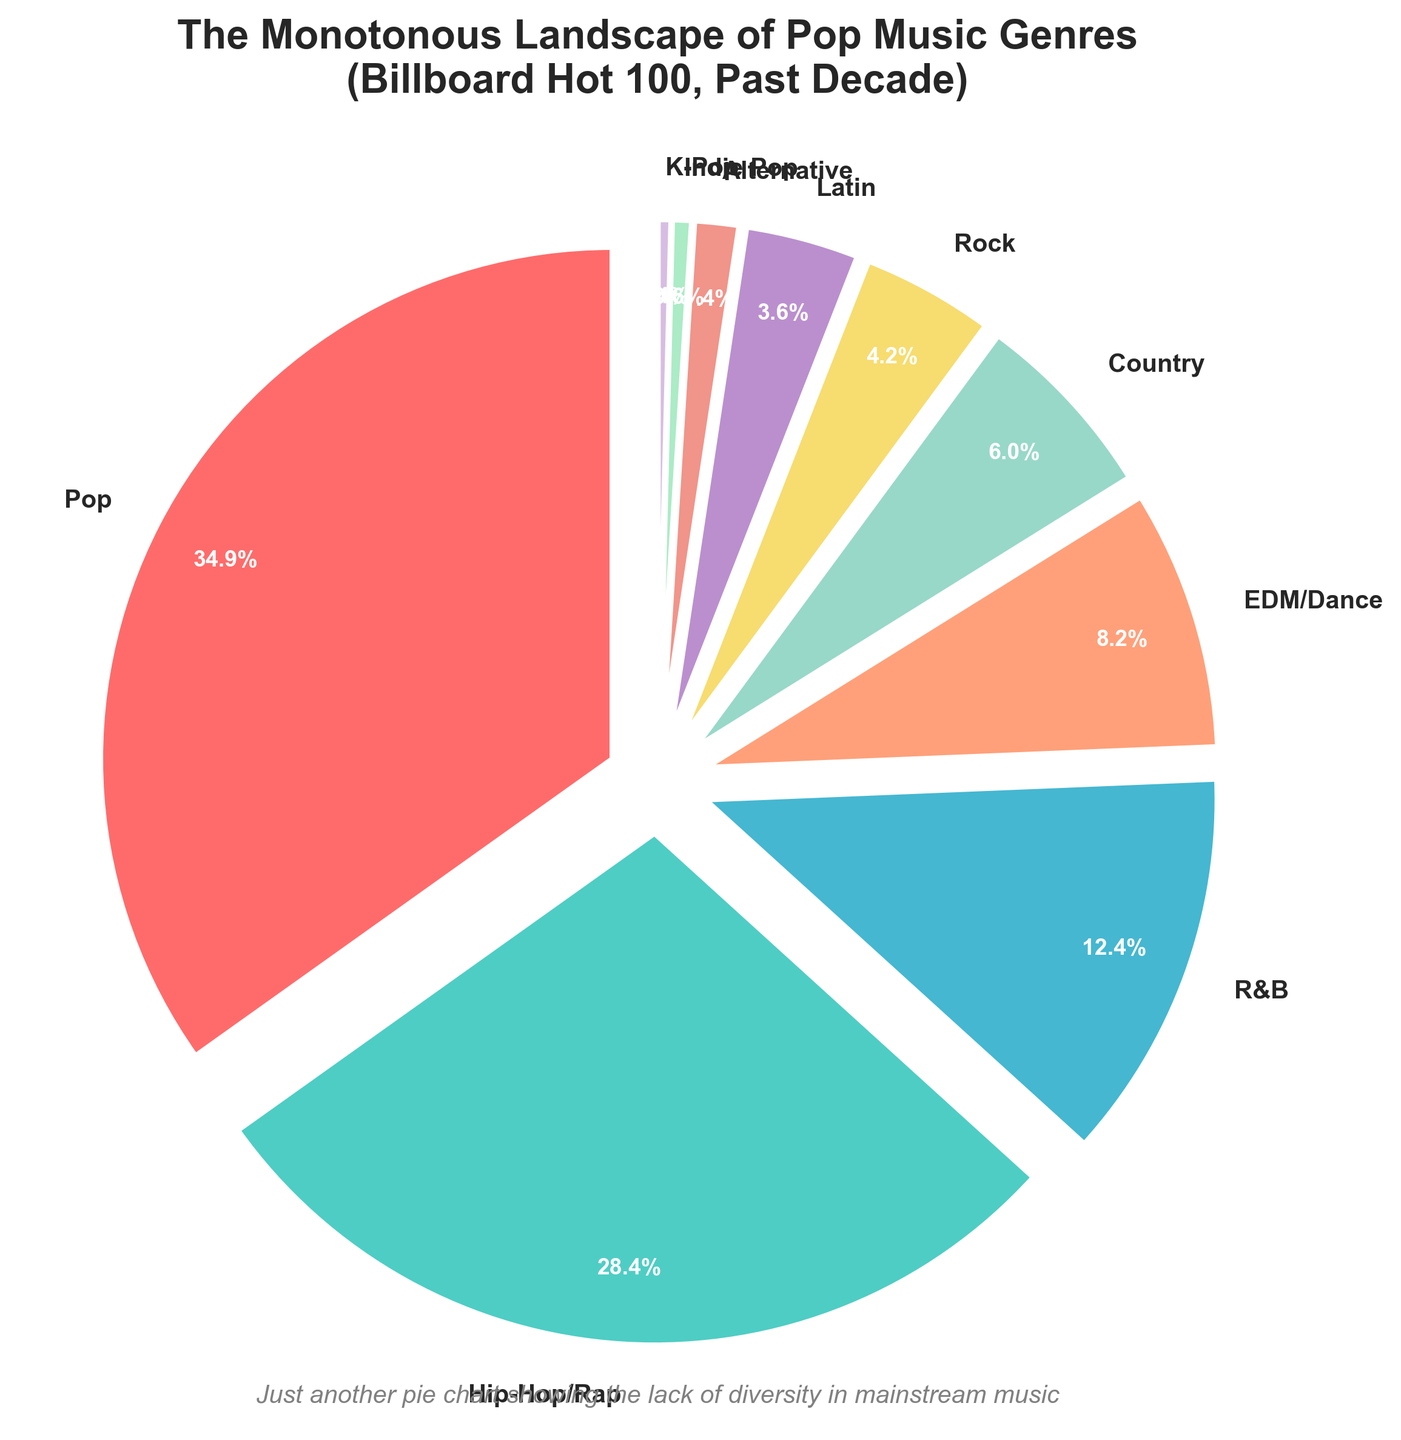Which genre holds the largest percentage in the Billboard Hot 100 over the past decade? The chart clearly shows that the "Pop" genre holds the largest percentage.
Answer: Pop How much higher is the percentage of Hip-Hop/Rap compared to Rock? Subtract the percentage of Rock from that of Hip-Hop/Rap: 28.7% - 4.2% = 24.5%.
Answer: 24.5% What is the combined percentage of R&B, EDM/Dance, and Country? Add the percentages of R&B, EDM/Dance, and Country: 12.5% + 8.3% + 6.1% = 26.9%.
Answer: 26.9% Which genre is depicted with the second-largest slice, and how does it compare to the largest one? The chart shows that Hip-Hop/Rap is the second-largest slice at 28.7%, and it is 6.5% less than the largest one, Pop at 35.2%.
Answer: Hip-Hop/Rap, 6.5% less How many genres have a percentage smaller than 5%? From the chart, the genres with percentages smaller than 5% are Rock, Latin, Alternative, Indie Pop, and K-Pop, making a total of 5 genres.
Answer: 5 Which genre is represented by the smallest slice, and what is its percentage? The smallest slice in the chart belongs to K-Pop, with a percentage of 0.4%.
Answer: K-Pop, 0.4% What is the average percentage of the genres listed in the Billboard Hot 100 chart? Sum all percentages (35.2% + 28.7% + 12.5% + 8.3% + 6.1% + 4.2% + 3.6% + 1.4% + 0.6% + 0.4%) = 101%, then divide by 10 genres. The average is 10.1% per genre.
Answer: 10.1% Combine the percentages of Indie Pop and K-Pop. What fraction of the total does this combination represent? Add the percentages of Indie Pop and K-Pop: 0.6% + 0.4% = 1%. This combination represents 1% of the total.
Answer: 1% What color is used for representing the "R&B" genre in the chart? The genre "R&B" is depicted in light blue color in the pie chart.
Answer: Light Blue Out of the alternative genres (Alternative, Indie Pop, and K-Pop), which one has the highest percentage and what is it? Among Alternative (1.4%), Indie Pop (0.6%), and K-Pop (0.4%), Alternative has the highest percentage at 1.4%.
Answer: Alternative, 1.4% 